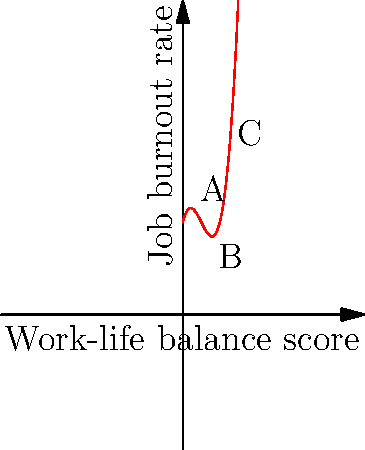The graph above represents the relationship between work-life balance scores (x-axis) and job burnout rates (y-axis) for mental health professionals. The trend is modeled by a third-degree polynomial function. At which point does the graph suggest the most optimal work-life balance score for minimizing job burnout? To find the optimal work-life balance score for minimizing job burnout, we need to identify the minimum point of the polynomial function. Here's how we can determine this:

1. The graph is a third-degree polynomial, which typically has an S-shape or reverse S-shape.

2. We can see that the function decreases from point A to point B, then increases from point B to point C.

3. The minimum point of the function occurs at the lowest point of the curve, which is at point B.

4. Point B corresponds to a work-life balance score of 3 on the x-axis.

5. This minimum point indicates that a work-life balance score of 3 is associated with the lowest job burnout rate for mental health professionals.

6. Scores lower or higher than 3 are associated with higher burnout rates, as shown by the curve's shape.

Therefore, according to this model, a work-life balance score of 3 suggests the most optimal condition for minimizing job burnout among mental health professionals.
Answer: Point B (work-life balance score of 3) 